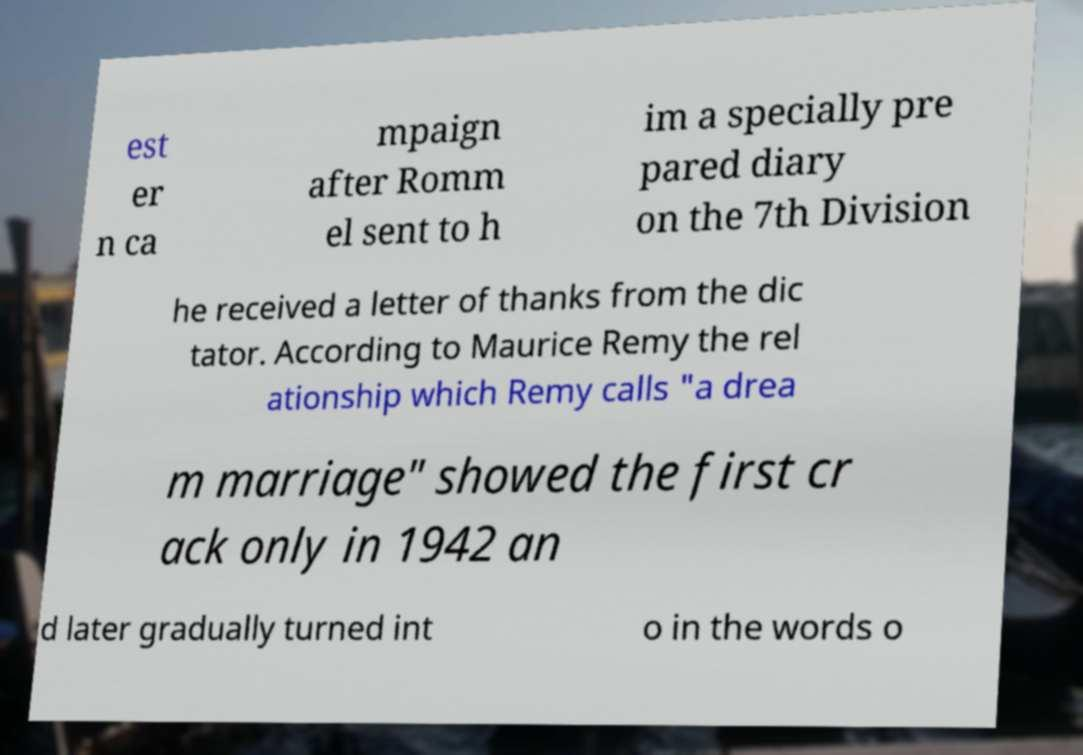Can you read and provide the text displayed in the image?This photo seems to have some interesting text. Can you extract and type it out for me? est er n ca mpaign after Romm el sent to h im a specially pre pared diary on the 7th Division he received a letter of thanks from the dic tator. According to Maurice Remy the rel ationship which Remy calls "a drea m marriage" showed the first cr ack only in 1942 an d later gradually turned int o in the words o 